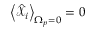<formula> <loc_0><loc_0><loc_500><loc_500>\left < \hat { \mathcal { X } } _ { i } \right > _ { \Omega _ { p } = 0 } = 0</formula> 